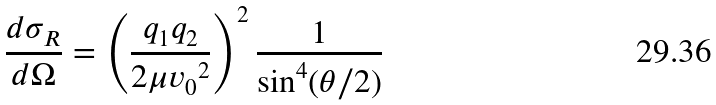<formula> <loc_0><loc_0><loc_500><loc_500>\frac { d \sigma _ { R } } { d \Omega } = \left ( \frac { q _ { 1 } q _ { 2 } } { 2 \mu { v _ { 0 } } ^ { 2 } } \right ) ^ { 2 } \frac { 1 } { \sin ^ { 4 } ( \theta / 2 ) }</formula> 